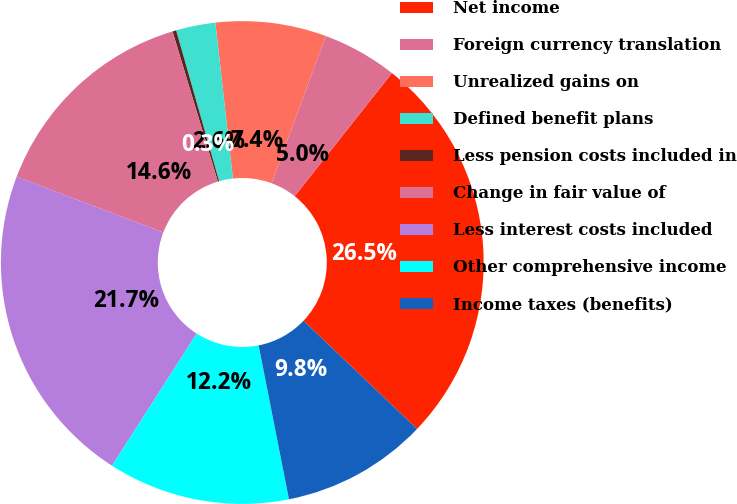Convert chart to OTSL. <chart><loc_0><loc_0><loc_500><loc_500><pie_chart><fcel>Net income<fcel>Foreign currency translation<fcel>Unrealized gains on<fcel>Defined benefit plans<fcel>Less pension costs included in<fcel>Change in fair value of<fcel>Less interest costs included<fcel>Other comprehensive income<fcel>Income taxes (benefits)<nl><fcel>26.47%<fcel>5.02%<fcel>7.4%<fcel>2.64%<fcel>0.25%<fcel>14.55%<fcel>21.71%<fcel>12.17%<fcel>9.79%<nl></chart> 